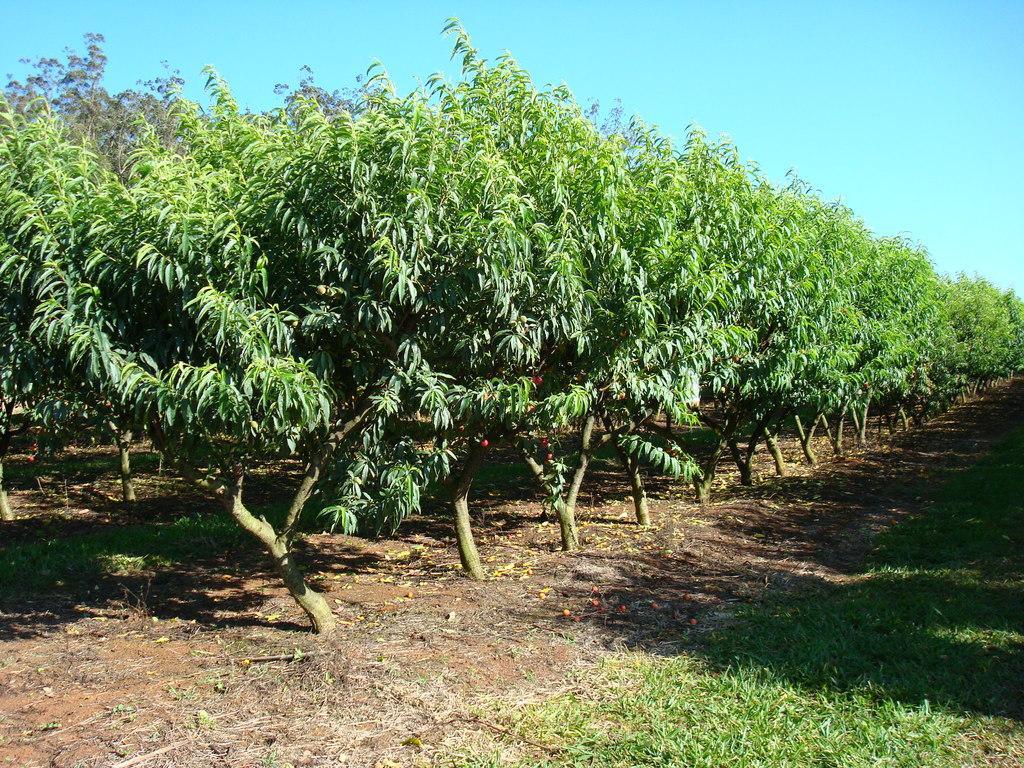Describe this image in one or two sentences. In this image we can see trees and at front there is a grass on the surface. At the background there is sky. 